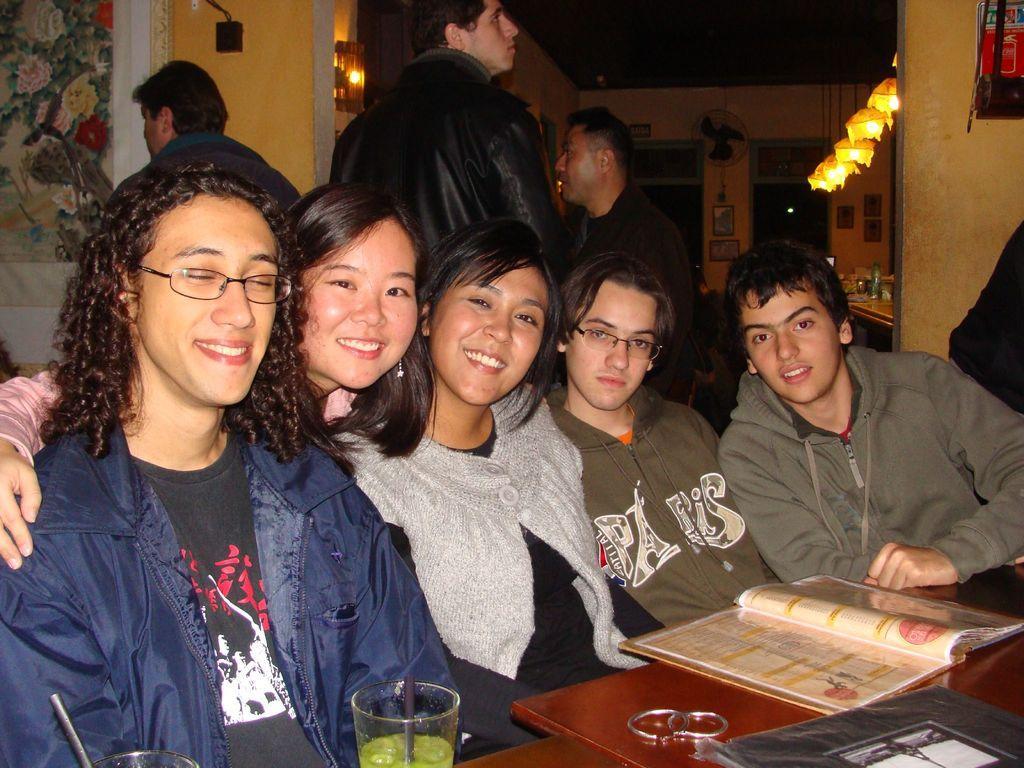Can you describe this image briefly? In front of the image there is a table. On top of it there are glasses, straws, books and there is a metal object. Behind the table there are a few people sitting and there are a few people standing. In the background of the image there are photo frames and a fan on the wall. There are lamps. There are some objects on the table. 